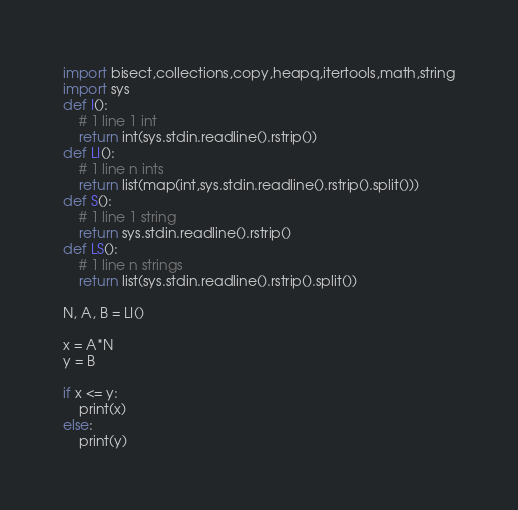<code> <loc_0><loc_0><loc_500><loc_500><_Python_>import bisect,collections,copy,heapq,itertools,math,string
import sys
def I():
    # 1 line 1 int
    return int(sys.stdin.readline().rstrip())
def LI():
    # 1 line n ints
    return list(map(int,sys.stdin.readline().rstrip().split()))
def S():
    # 1 line 1 string
    return sys.stdin.readline().rstrip()
def LS():
    # 1 line n strings
    return list(sys.stdin.readline().rstrip().split())

N, A, B = LI()

x = A*N
y = B

if x <= y:
    print(x)
else:
    print(y)

</code> 